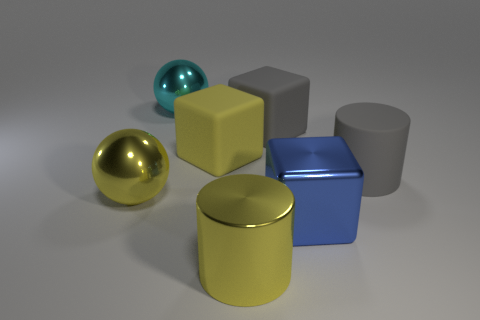There is a shiny block that is the same size as the gray rubber cylinder; what color is it?
Provide a succinct answer. Blue. What number of objects are gray cylinders on the right side of the large cyan metal object or yellow things that are to the left of the cyan metal thing?
Your answer should be compact. 2. How many things are cylinders or yellow objects?
Give a very brief answer. 4. What size is the shiny object that is both behind the blue shiny object and in front of the large cyan shiny sphere?
Provide a succinct answer. Large. What number of spheres are made of the same material as the big yellow block?
Your answer should be compact. 0. What is the color of the cylinder that is made of the same material as the blue object?
Your response must be concise. Yellow. There is a big block behind the yellow cube; is its color the same as the large matte cylinder?
Provide a short and direct response. Yes. What is the big sphere that is behind the yellow shiny sphere made of?
Offer a terse response. Metal. Are there an equal number of big gray things that are on the left side of the big yellow metallic ball and gray metal cylinders?
Offer a terse response. Yes. How many matte blocks are the same color as the large metallic cylinder?
Offer a very short reply. 1. 